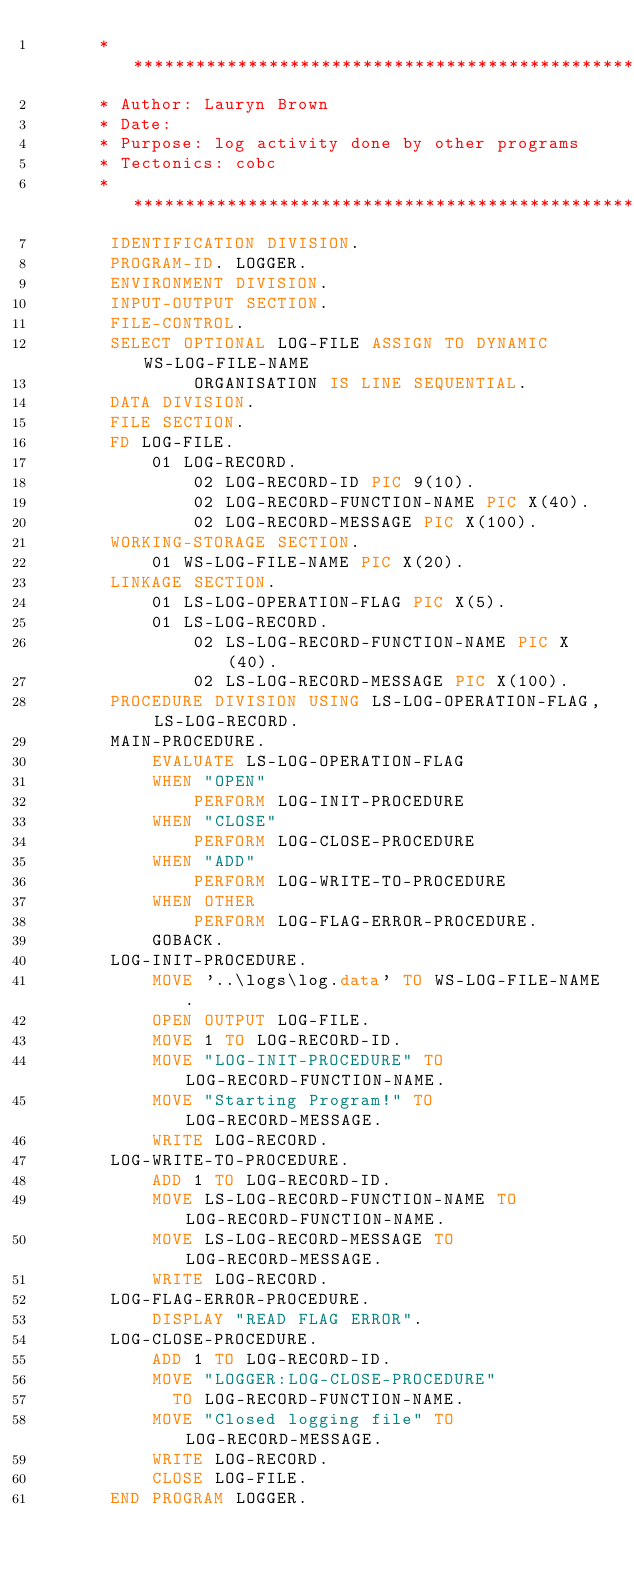Convert code to text. <code><loc_0><loc_0><loc_500><loc_500><_COBOL_>      ******************************************************************
      * Author: Lauryn Brown
      * Date:
      * Purpose: log activity done by other programs
      * Tectonics: cobc
      ******************************************************************
       IDENTIFICATION DIVISION.
       PROGRAM-ID. LOGGER.
       ENVIRONMENT DIVISION.
       INPUT-OUTPUT SECTION.
       FILE-CONTROL.
       SELECT OPTIONAL LOG-FILE ASSIGN TO DYNAMIC WS-LOG-FILE-NAME
               ORGANISATION IS LINE SEQUENTIAL.
       DATA DIVISION.
       FILE SECTION.
       FD LOG-FILE.
           01 LOG-RECORD.
               02 LOG-RECORD-ID PIC 9(10).
               02 LOG-RECORD-FUNCTION-NAME PIC X(40).
               02 LOG-RECORD-MESSAGE PIC X(100).
       WORKING-STORAGE SECTION.
           01 WS-LOG-FILE-NAME PIC X(20).
       LINKAGE SECTION.
           01 LS-LOG-OPERATION-FLAG PIC X(5).
           01 LS-LOG-RECORD.
               02 LS-LOG-RECORD-FUNCTION-NAME PIC X(40).
               02 LS-LOG-RECORD-MESSAGE PIC X(100).
       PROCEDURE DIVISION USING LS-LOG-OPERATION-FLAG, LS-LOG-RECORD.
       MAIN-PROCEDURE.
           EVALUATE LS-LOG-OPERATION-FLAG
           WHEN "OPEN"
               PERFORM LOG-INIT-PROCEDURE
           WHEN "CLOSE"
               PERFORM LOG-CLOSE-PROCEDURE
           WHEN "ADD"
               PERFORM LOG-WRITE-TO-PROCEDURE
           WHEN OTHER
               PERFORM LOG-FLAG-ERROR-PROCEDURE.
           GOBACK.
       LOG-INIT-PROCEDURE.
           MOVE '..\logs\log.data' TO WS-LOG-FILE-NAME.
           OPEN OUTPUT LOG-FILE.
           MOVE 1 TO LOG-RECORD-ID.
           MOVE "LOG-INIT-PROCEDURE" TO LOG-RECORD-FUNCTION-NAME.
           MOVE "Starting Program!" TO LOG-RECORD-MESSAGE.
           WRITE LOG-RECORD.
       LOG-WRITE-TO-PROCEDURE.
           ADD 1 TO LOG-RECORD-ID.
           MOVE LS-LOG-RECORD-FUNCTION-NAME TO LOG-RECORD-FUNCTION-NAME.
           MOVE LS-LOG-RECORD-MESSAGE TO LOG-RECORD-MESSAGE.
           WRITE LOG-RECORD.
       LOG-FLAG-ERROR-PROCEDURE.
           DISPLAY "READ FLAG ERROR".
       LOG-CLOSE-PROCEDURE.
           ADD 1 TO LOG-RECORD-ID.
           MOVE "LOGGER:LOG-CLOSE-PROCEDURE"
             TO LOG-RECORD-FUNCTION-NAME.
           MOVE "Closed logging file" TO LOG-RECORD-MESSAGE.
           WRITE LOG-RECORD.
           CLOSE LOG-FILE.
       END PROGRAM LOGGER.
</code> 